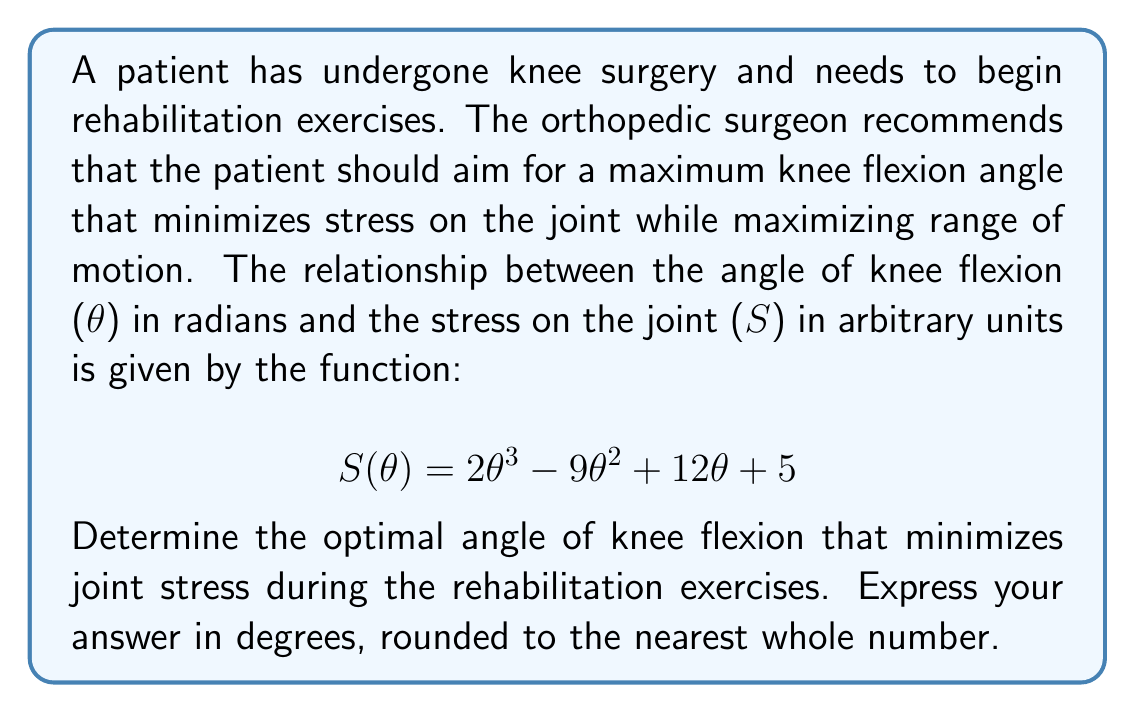Could you help me with this problem? To find the optimal angle that minimizes joint stress, we need to find the minimum of the function $S(\theta)$. This can be done by following these steps:

1) First, we need to find the derivative of $S(\theta)$:

   $$S'(\theta) = 6\theta^2 - 18\theta + 12$$

2) To find the minimum, we set $S'(\theta) = 0$ and solve for $\theta$:

   $$6\theta^2 - 18\theta + 12 = 0$$

3) This is a quadratic equation. We can solve it using the quadratic formula:

   $$\theta = \frac{-b \pm \sqrt{b^2 - 4ac}}{2a}$$

   Where $a = 6$, $b = -18$, and $c = 12$

4) Substituting these values:

   $$\theta = \frac{18 \pm \sqrt{(-18)^2 - 4(6)(12)}}{2(6)}$$
   $$= \frac{18 \pm \sqrt{324 - 288}}{12}$$
   $$= \frac{18 \pm \sqrt{36}}{12}$$
   $$= \frac{18 \pm 6}{12}$$

5) This gives us two solutions:

   $$\theta_1 = \frac{18 + 6}{12} = 2$$
   $$\theta_2 = \frac{18 - 6}{12} = 1$$

6) To determine which of these is the minimum (rather than a maximum), we can check the second derivative:

   $$S''(\theta) = 12\theta - 18$$

   At $\theta = 2$: $S''(2) = 12(2) - 18 = 6 > 0$
   At $\theta = 1$: $S''(1) = 12(1) - 18 = -6 < 0$

   Since $S''(2) > 0$, $\theta = 2$ gives us the minimum.

7) Finally, we need to convert 2 radians to degrees:

   $$2 \text{ radians} = 2 \times \frac{180°}{\pi} \approx 114.6°$$

Rounding to the nearest whole number, we get 115°.
Answer: 115° 